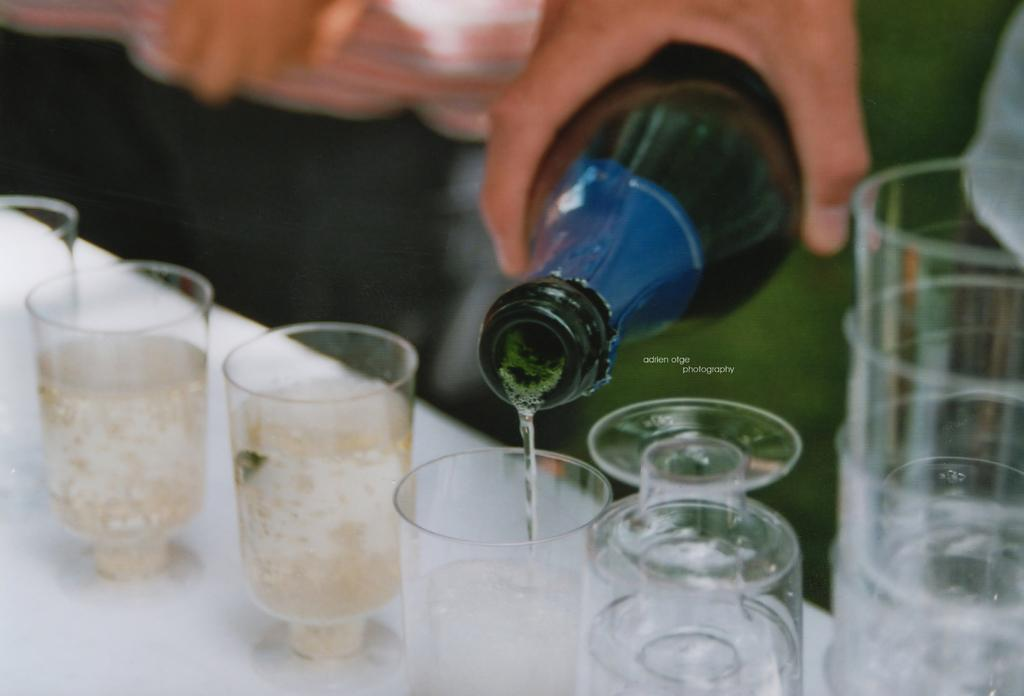What objects are on the table in the image? There are glasses on a table in the image. What is inside the glasses? The glasses contain a drink. What else can be seen in the image besides the glasses? There is a bottle in the image. Who is holding the bottle? A person's hand is holding the bottle. What is the person doing with the bottle? The person's hand is pouring the drink into the glasses. Can you describe the background of the image? The background of the image is blurred. What type of creature is sitting on the table next to the glasses? There is no creature present on the table next to the glasses in the image. How many cherries are on top of the drink in the glasses? There are no cherries visible in the image; the glasses contain a drink without any visible fruit. 